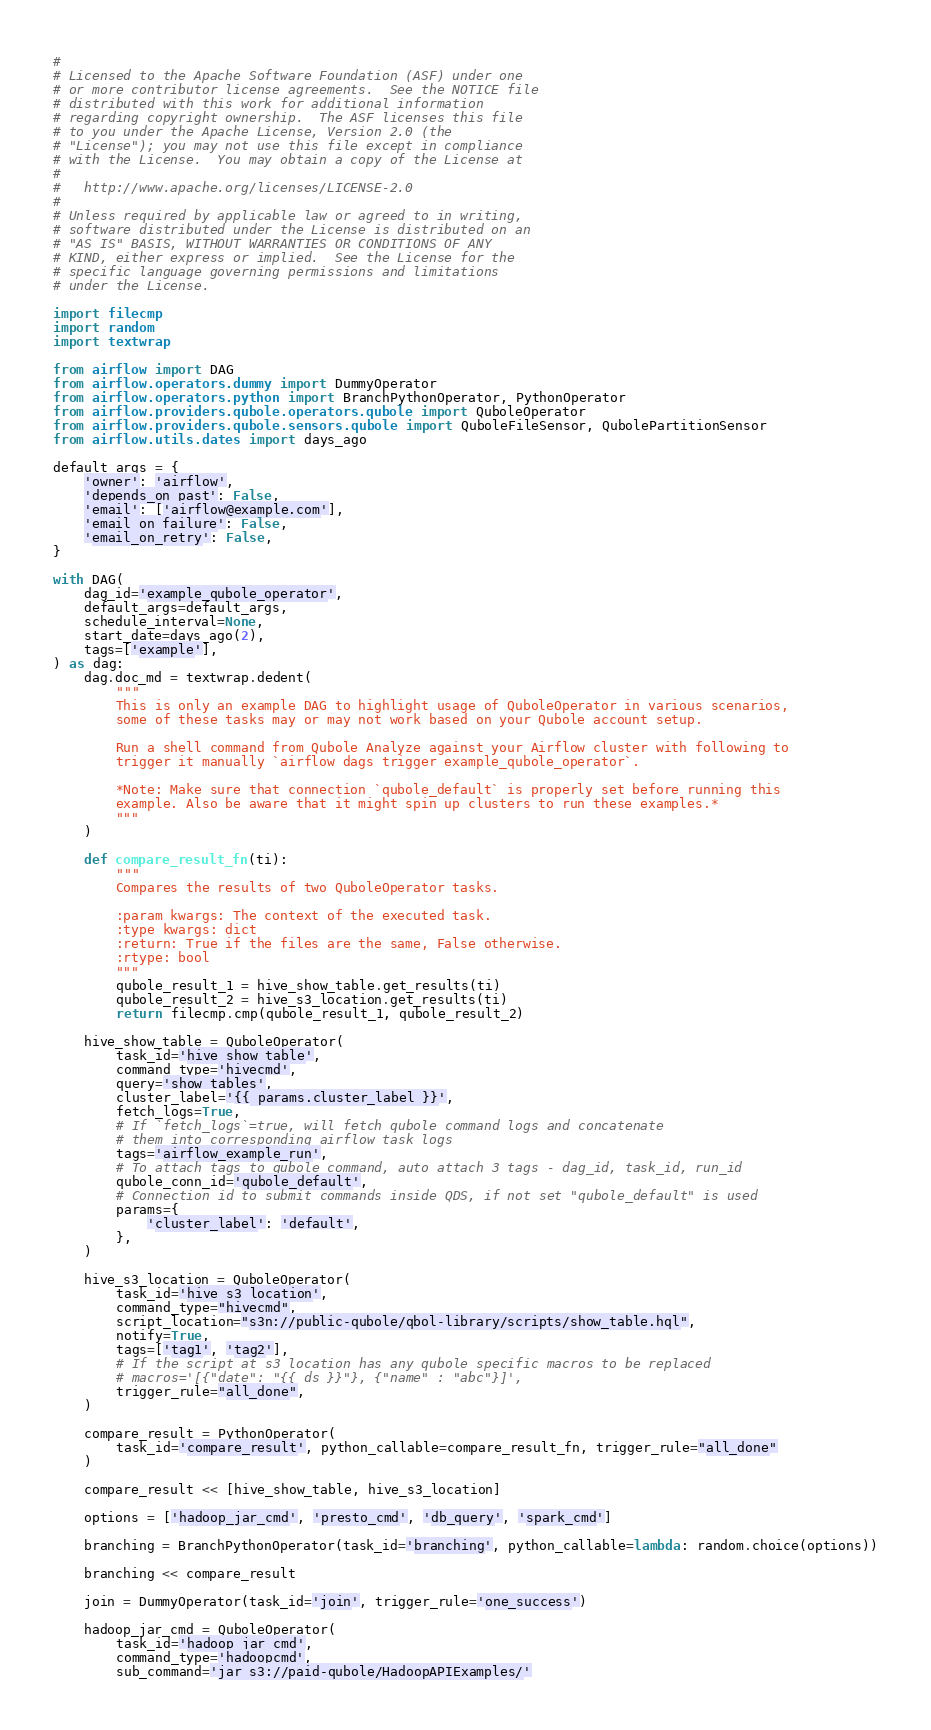Convert code to text. <code><loc_0><loc_0><loc_500><loc_500><_Python_>#
# Licensed to the Apache Software Foundation (ASF) under one
# or more contributor license agreements.  See the NOTICE file
# distributed with this work for additional information
# regarding copyright ownership.  The ASF licenses this file
# to you under the Apache License, Version 2.0 (the
# "License"); you may not use this file except in compliance
# with the License.  You may obtain a copy of the License at
#
#   http://www.apache.org/licenses/LICENSE-2.0
#
# Unless required by applicable law or agreed to in writing,
# software distributed under the License is distributed on an
# "AS IS" BASIS, WITHOUT WARRANTIES OR CONDITIONS OF ANY
# KIND, either express or implied.  See the License for the
# specific language governing permissions and limitations
# under the License.

import filecmp
import random
import textwrap

from airflow import DAG
from airflow.operators.dummy import DummyOperator
from airflow.operators.python import BranchPythonOperator, PythonOperator
from airflow.providers.qubole.operators.qubole import QuboleOperator
from airflow.providers.qubole.sensors.qubole import QuboleFileSensor, QubolePartitionSensor
from airflow.utils.dates import days_ago

default_args = {
    'owner': 'airflow',
    'depends_on_past': False,
    'email': ['airflow@example.com'],
    'email_on_failure': False,
    'email_on_retry': False,
}

with DAG(
    dag_id='example_qubole_operator',
    default_args=default_args,
    schedule_interval=None,
    start_date=days_ago(2),
    tags=['example'],
) as dag:
    dag.doc_md = textwrap.dedent(
        """
        This is only an example DAG to highlight usage of QuboleOperator in various scenarios,
        some of these tasks may or may not work based on your Qubole account setup.

        Run a shell command from Qubole Analyze against your Airflow cluster with following to
        trigger it manually `airflow dags trigger example_qubole_operator`.

        *Note: Make sure that connection `qubole_default` is properly set before running this
        example. Also be aware that it might spin up clusters to run these examples.*
        """
    )

    def compare_result_fn(ti):
        """
        Compares the results of two QuboleOperator tasks.

        :param kwargs: The context of the executed task.
        :type kwargs: dict
        :return: True if the files are the same, False otherwise.
        :rtype: bool
        """
        qubole_result_1 = hive_show_table.get_results(ti)
        qubole_result_2 = hive_s3_location.get_results(ti)
        return filecmp.cmp(qubole_result_1, qubole_result_2)

    hive_show_table = QuboleOperator(
        task_id='hive_show_table',
        command_type='hivecmd',
        query='show tables',
        cluster_label='{{ params.cluster_label }}',
        fetch_logs=True,
        # If `fetch_logs`=true, will fetch qubole command logs and concatenate
        # them into corresponding airflow task logs
        tags='airflow_example_run',
        # To attach tags to qubole command, auto attach 3 tags - dag_id, task_id, run_id
        qubole_conn_id='qubole_default',
        # Connection id to submit commands inside QDS, if not set "qubole_default" is used
        params={
            'cluster_label': 'default',
        },
    )

    hive_s3_location = QuboleOperator(
        task_id='hive_s3_location',
        command_type="hivecmd",
        script_location="s3n://public-qubole/qbol-library/scripts/show_table.hql",
        notify=True,
        tags=['tag1', 'tag2'],
        # If the script at s3 location has any qubole specific macros to be replaced
        # macros='[{"date": "{{ ds }}"}, {"name" : "abc"}]',
        trigger_rule="all_done",
    )

    compare_result = PythonOperator(
        task_id='compare_result', python_callable=compare_result_fn, trigger_rule="all_done"
    )

    compare_result << [hive_show_table, hive_s3_location]

    options = ['hadoop_jar_cmd', 'presto_cmd', 'db_query', 'spark_cmd']

    branching = BranchPythonOperator(task_id='branching', python_callable=lambda: random.choice(options))

    branching << compare_result

    join = DummyOperator(task_id='join', trigger_rule='one_success')

    hadoop_jar_cmd = QuboleOperator(
        task_id='hadoop_jar_cmd',
        command_type='hadoopcmd',
        sub_command='jar s3://paid-qubole/HadoopAPIExamples/'</code> 